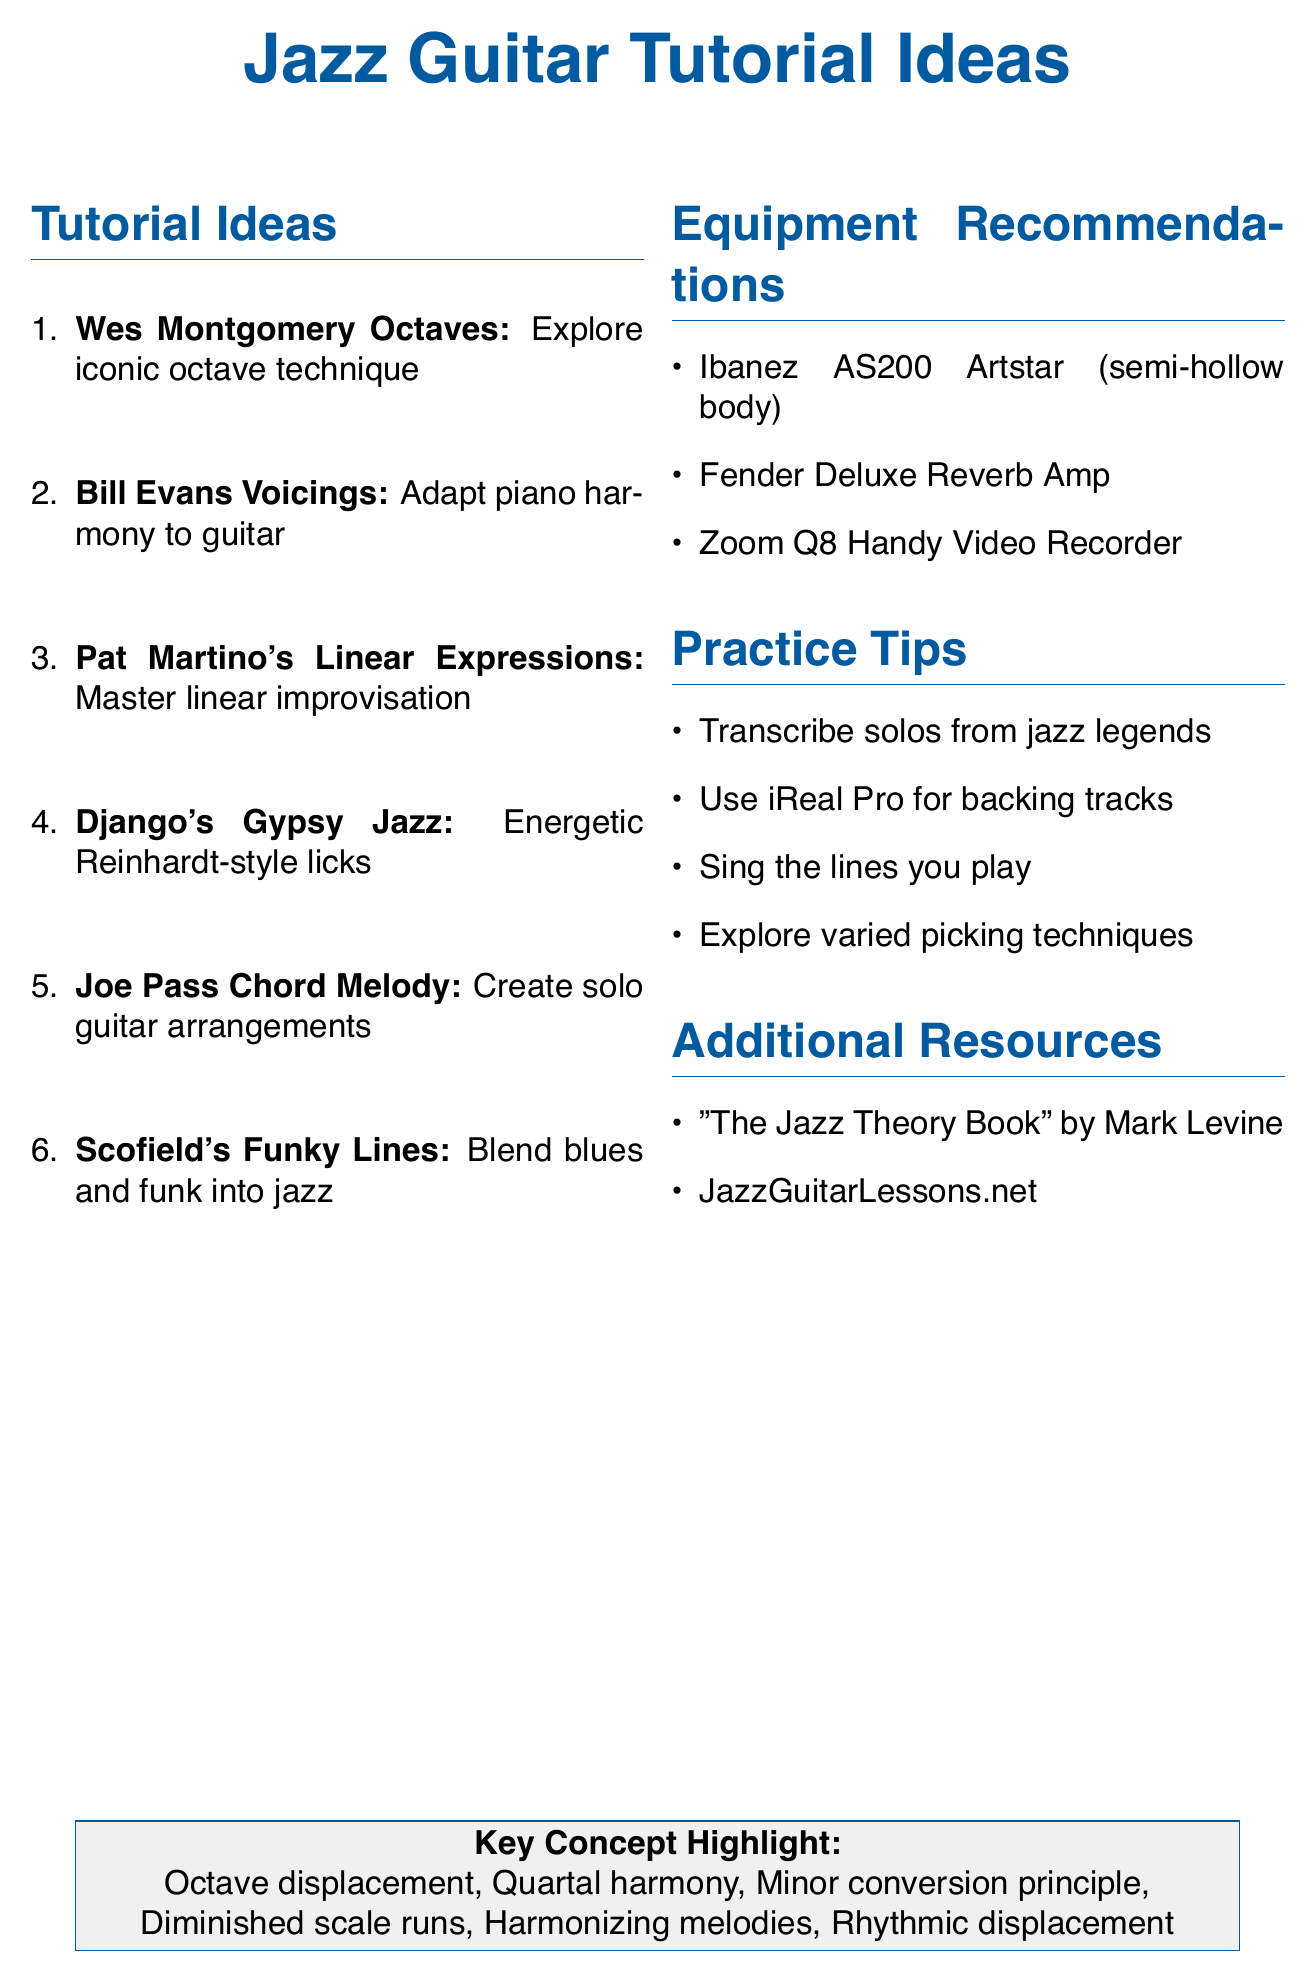What is the title of the first tutorial idea? The title of the first tutorial idea is listed as "Wes Montgomery-inspired Octave Licks."
Answer: Wes Montgomery-inspired Octave Licks What is a key concept associated with Django Reinhardt's Licks? Django Reinhardt's Licks include "Diminished scale runs" as one of the key concepts.
Answer: Diminished scale runs What equipment is recommended for capturing high-quality video and audio? The document lists "Zoom Q8 Handy Video Recorder" as the equipment recommended for capturing high-quality video and audio.
Answer: Zoom Q8 Handy Video Recorder What practice tip is suggested for developing your ear? The document mentions "Develop your ear by singing the lines you play on guitar" as a suggested practice tip.
Answer: Singing the lines you play on guitar How many tutorial ideas are listed in total? The document has six tutorial ideas listed in the tutorial ideas section.
Answer: Six Which jazz guitar legend is mentioned for transcription in the practice tips? The document recommends transcribing solos from "Jim Hall" as one of the practice tips.
Answer: Jim Hall What is the author of "The Jazz Theory Book"? The document identifies "Mark Levine" as the author of "The Jazz Theory Book."
Answer: Mark Levine Which two techniques are associated with Joe Pass? "Harmonizing melodies" and "Walking bass lines" are listed as techniques associated with Joe Pass.
Answer: Harmonizing melodies, Walking bass lines 